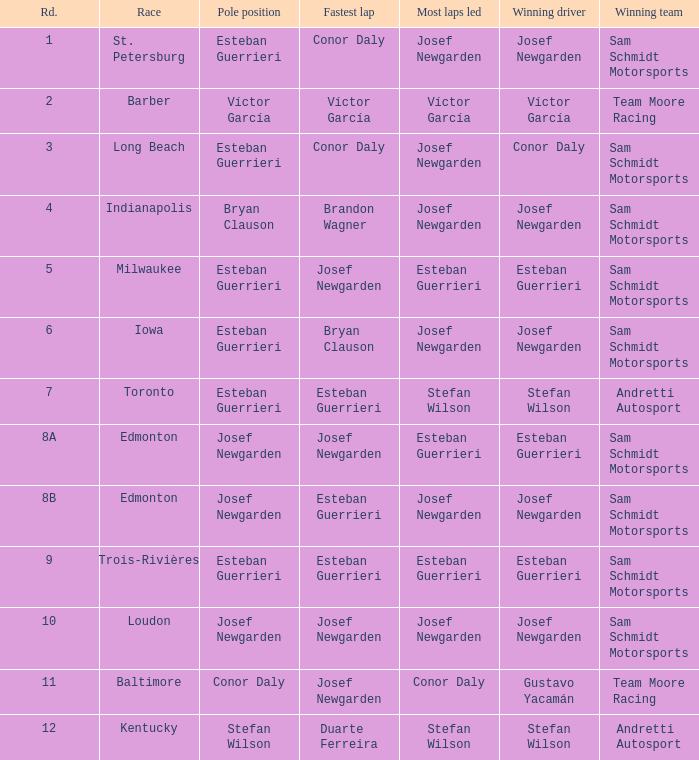Who achieved the quickest lap(s) when josef newgarden dominated the most laps at edmonton? Esteban Guerrieri. 